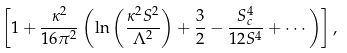<formula> <loc_0><loc_0><loc_500><loc_500>\left [ 1 + \frac { \kappa ^ { 2 } } { 1 6 \pi ^ { 2 } } \left ( \ln \left ( \frac { \kappa ^ { 2 } S ^ { 2 } } { \Lambda ^ { 2 } } \right ) + \frac { 3 } { 2 } - \frac { S _ { c } ^ { 4 } } { 1 2 S ^ { 4 } } + \cdots \right ) \right ] ,</formula> 